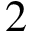<formula> <loc_0><loc_0><loc_500><loc_500>2</formula> 